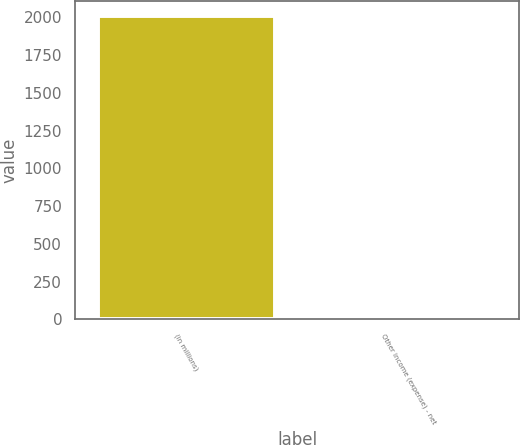<chart> <loc_0><loc_0><loc_500><loc_500><bar_chart><fcel>(in millions)<fcel>Other income (expense) - net<nl><fcel>2010<fcel>2<nl></chart> 